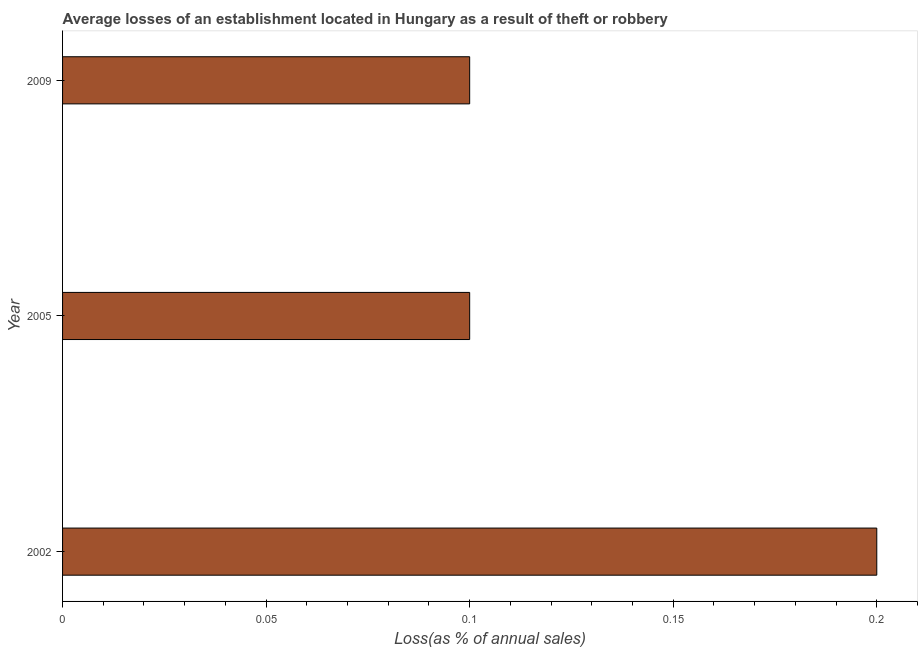What is the title of the graph?
Offer a terse response. Average losses of an establishment located in Hungary as a result of theft or robbery. What is the label or title of the X-axis?
Your response must be concise. Loss(as % of annual sales). Across all years, what is the maximum losses due to theft?
Your answer should be compact. 0.2. Across all years, what is the minimum losses due to theft?
Provide a short and direct response. 0.1. In which year was the losses due to theft maximum?
Give a very brief answer. 2002. What is the sum of the losses due to theft?
Your answer should be very brief. 0.4. What is the average losses due to theft per year?
Provide a short and direct response. 0.13. Do a majority of the years between 2002 and 2005 (inclusive) have losses due to theft greater than 0.17 %?
Your answer should be compact. No. Is the sum of the losses due to theft in 2005 and 2009 greater than the maximum losses due to theft across all years?
Ensure brevity in your answer.  No. How many years are there in the graph?
Provide a short and direct response. 3. What is the difference between two consecutive major ticks on the X-axis?
Provide a succinct answer. 0.05. What is the Loss(as % of annual sales) in 2009?
Give a very brief answer. 0.1. What is the difference between the Loss(as % of annual sales) in 2002 and 2005?
Provide a succinct answer. 0.1. What is the difference between the Loss(as % of annual sales) in 2005 and 2009?
Give a very brief answer. 0. What is the ratio of the Loss(as % of annual sales) in 2002 to that in 2005?
Your response must be concise. 2. What is the ratio of the Loss(as % of annual sales) in 2005 to that in 2009?
Your response must be concise. 1. 